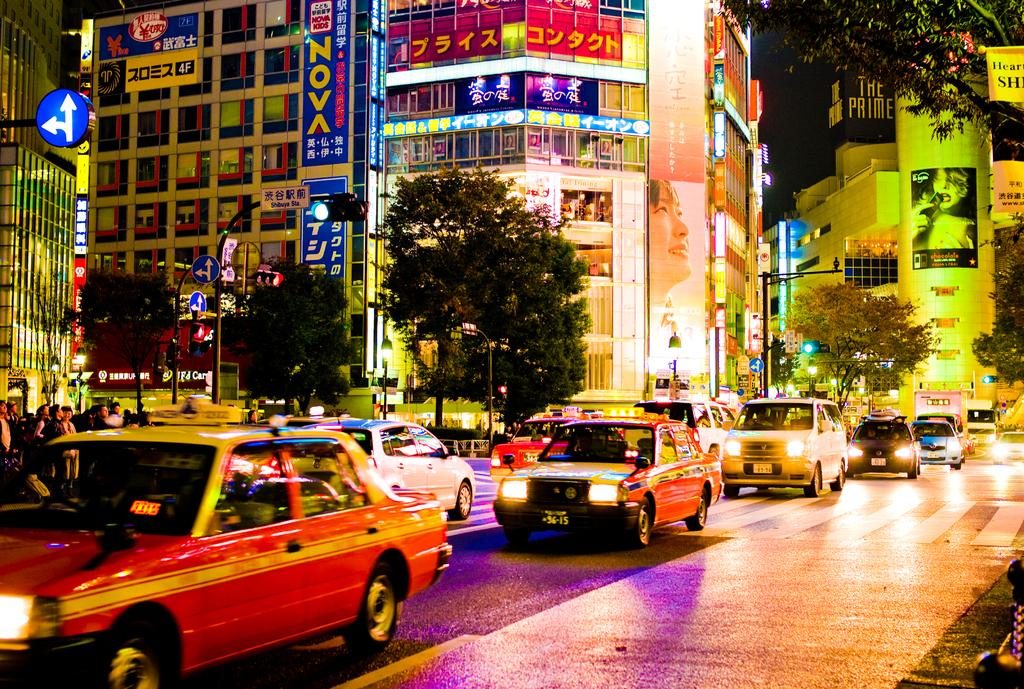Provide a one-sentence caption for the provided image. A night time city street with taxis and a sign that says Nova. 